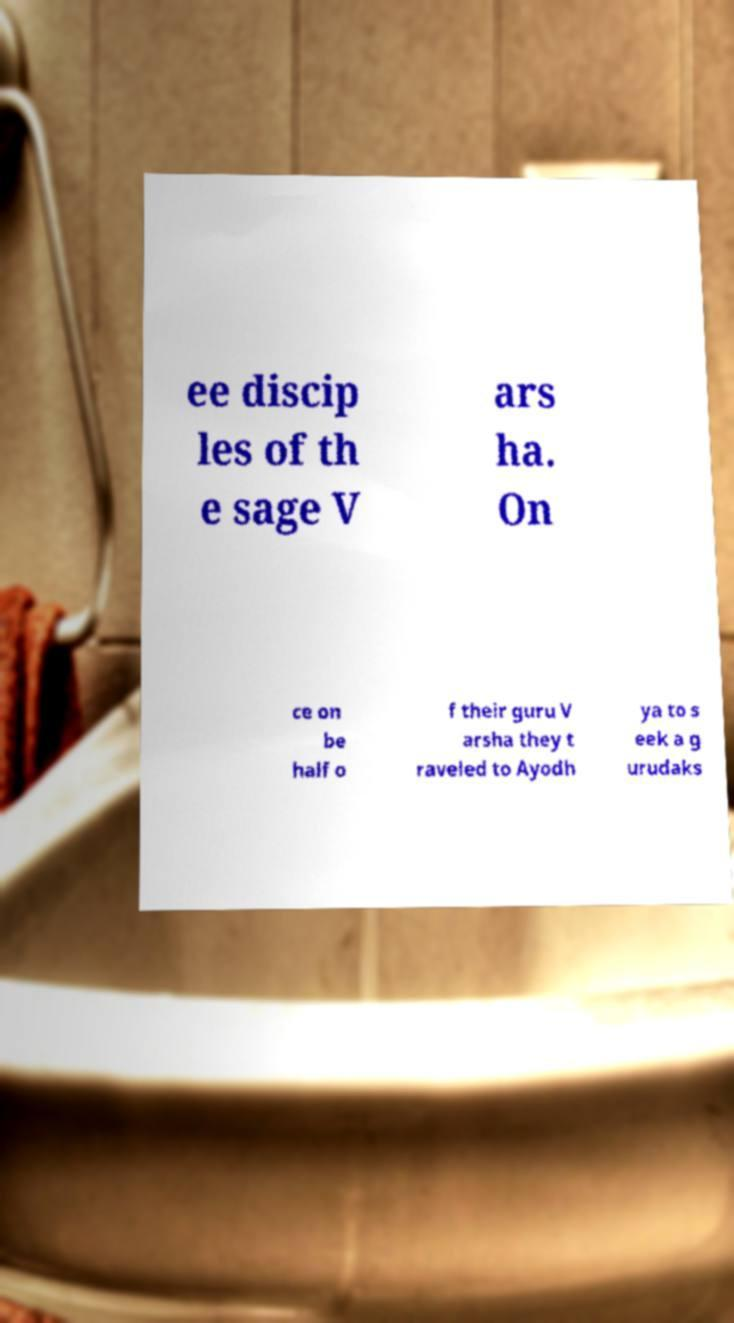For documentation purposes, I need the text within this image transcribed. Could you provide that? ee discip les of th e sage V ars ha. On ce on be half o f their guru V arsha they t raveled to Ayodh ya to s eek a g urudaks 